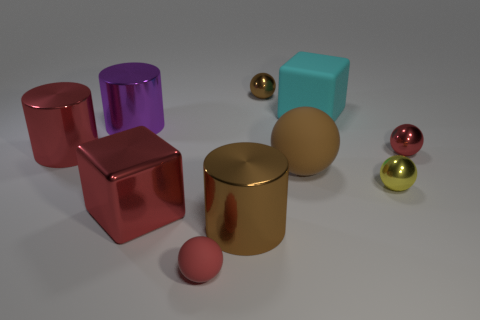What is the material of the big red object that is the same shape as the big purple object?
Your answer should be compact. Metal. How many things are big cubes in front of the large brown matte thing or shiny spheres?
Your answer should be very brief. 4. There is a big red object that is the same material as the big red cylinder; what is its shape?
Make the answer very short. Cube. What number of other small objects are the same shape as the tiny yellow metal thing?
Keep it short and to the point. 3. What is the material of the big brown ball?
Your answer should be very brief. Rubber. There is a tiny matte object; does it have the same color as the big shiny thing that is in front of the big red metallic block?
Ensure brevity in your answer.  No. How many cubes are tiny brown things or large shiny objects?
Your response must be concise. 1. What is the color of the metal thing to the right of the small yellow metallic object?
Offer a very short reply. Red. There is another tiny object that is the same color as the small rubber thing; what is its shape?
Give a very brief answer. Sphere. How many green cylinders are the same size as the red shiny block?
Your answer should be very brief. 0. 